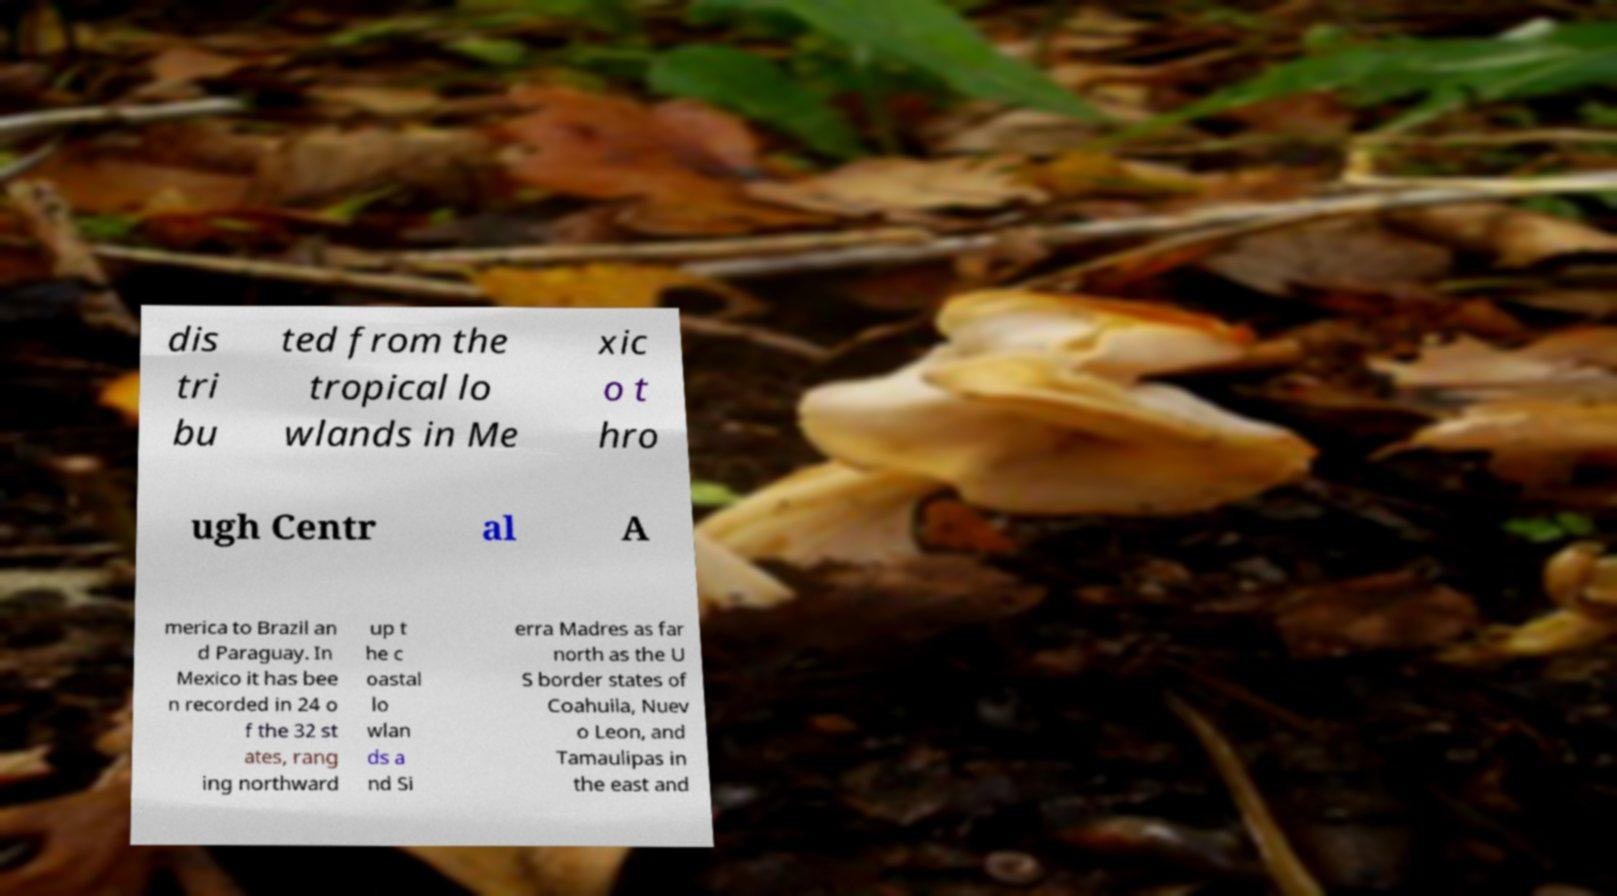I need the written content from this picture converted into text. Can you do that? dis tri bu ted from the tropical lo wlands in Me xic o t hro ugh Centr al A merica to Brazil an d Paraguay. In Mexico it has bee n recorded in 24 o f the 32 st ates, rang ing northward up t he c oastal lo wlan ds a nd Si erra Madres as far north as the U S border states of Coahuila, Nuev o Leon, and Tamaulipas in the east and 